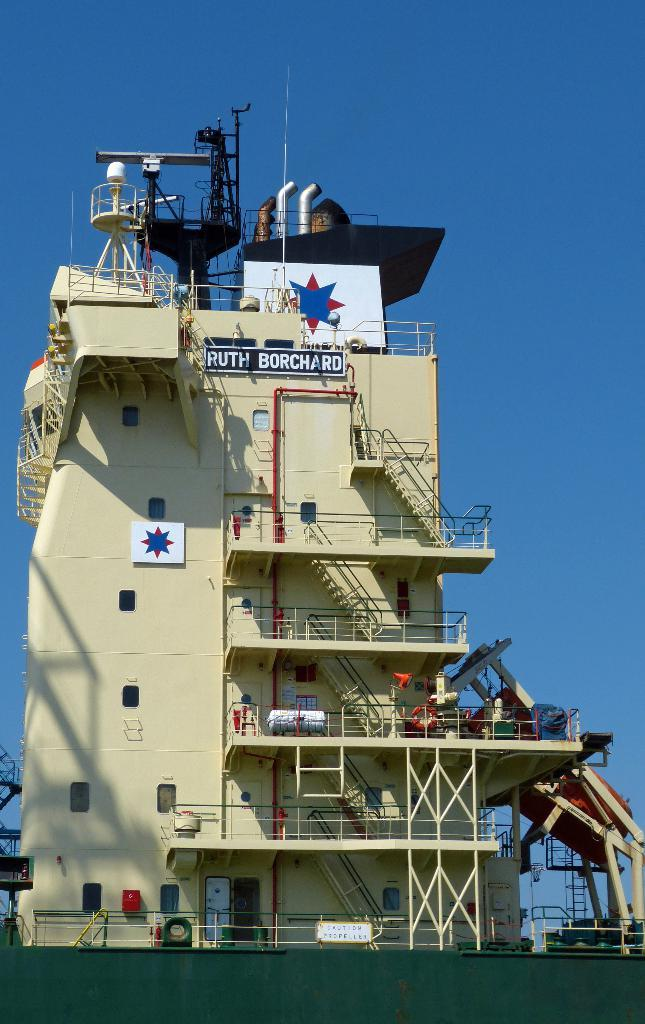What type of building is in the picture? There is an industrial building in the picture. What features can be seen on the building? The building has pipes, windows, and a metal staircase. What is visible at the top of the picture? The sky is clear and visible at the top of the picture. How many branches can be seen on the heart in the image? There is no heart or branches present in the image; it features an industrial building with pipes, windows, and a metal staircase. 